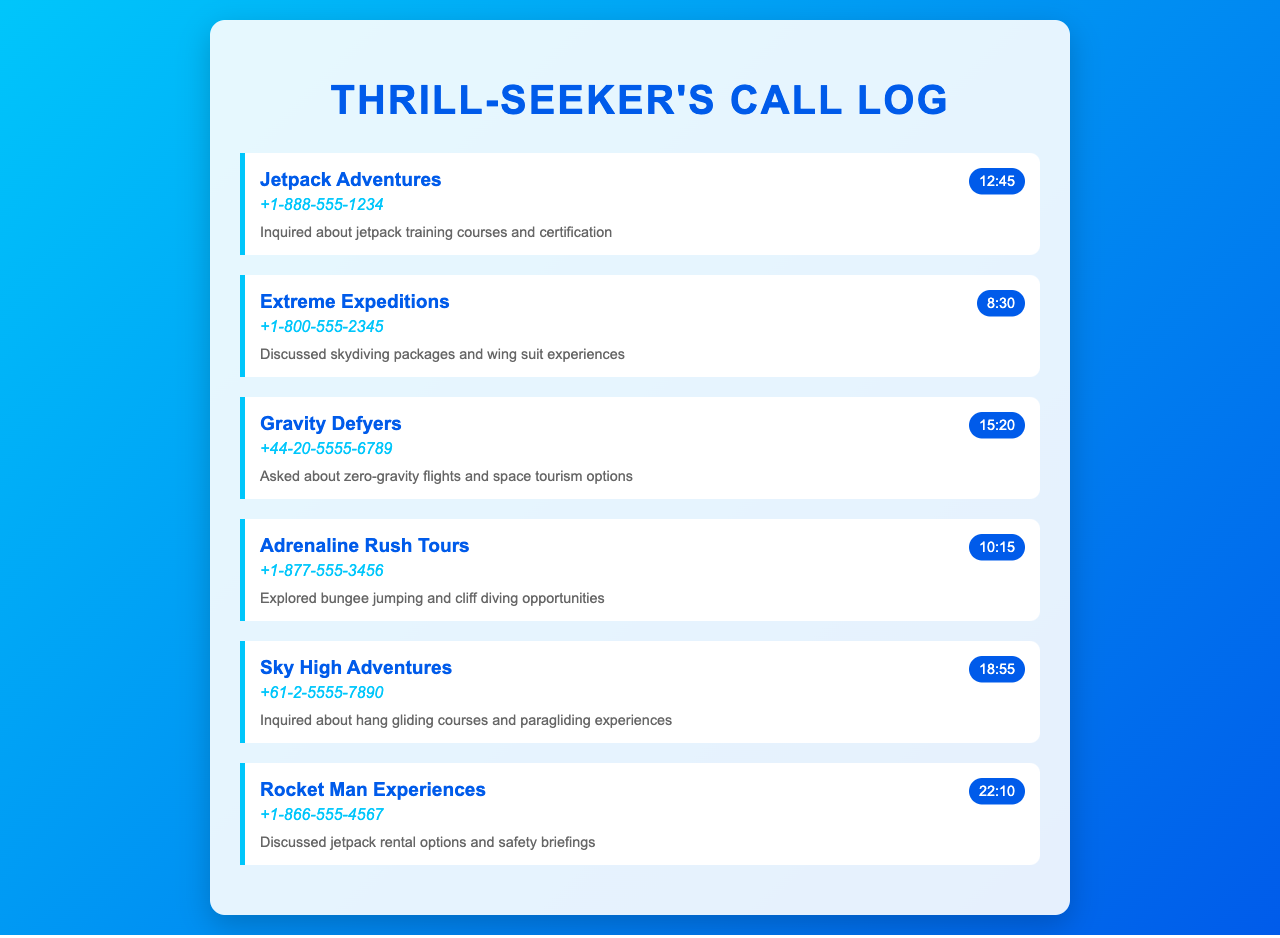What is the phone number for Jetpack Adventures? The phone number for Jetpack Adventures can be found in the document under the company's name.
Answer: +1-888-555-1234 How long was the call with Gravity Defyers? The call duration with Gravity Defyers is provided in the document.
Answer: 15:20 What type of experiences does Sky High Adventures offer? The document mentions that Sky High Adventures provides information about hang gliding courses and paragliding experiences.
Answer: Hang gliding and paragliding Which company was discussed regarding jetpack rental options? The company associated with jetpack rental options is mentioned in the call records.
Answer: Rocket Man Experiences How many different adventure travel agencies are listed in the call log? The number of different agencies can be counted from the records listed.
Answer: Six 